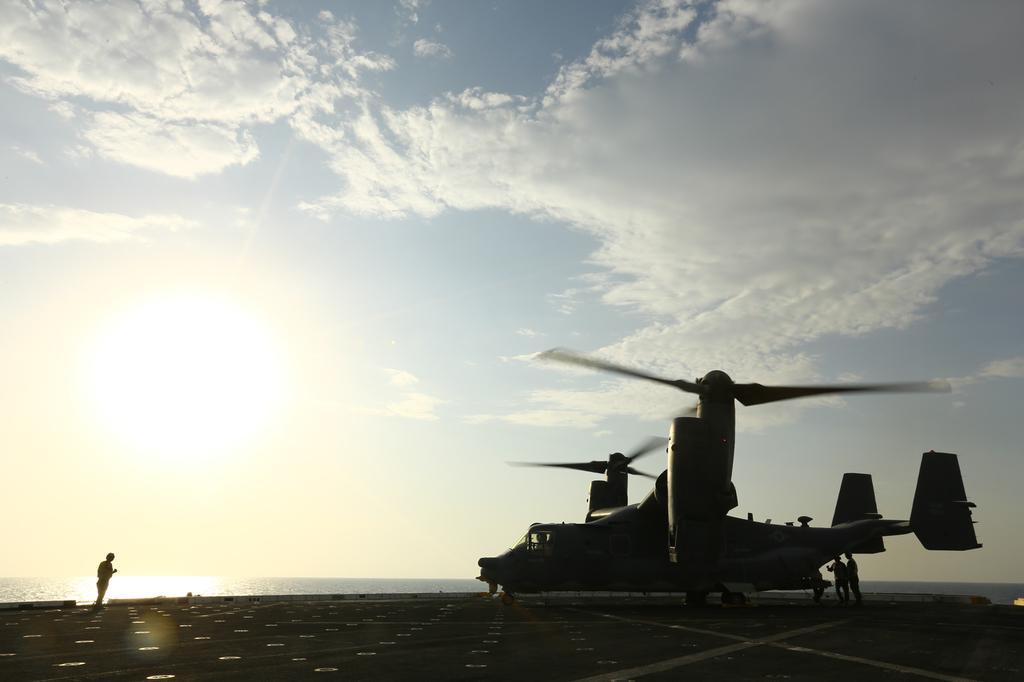Could you give a brief overview of what you see in this image? In this picture we can see few people and a helicopter on the ship, and we can find water. 